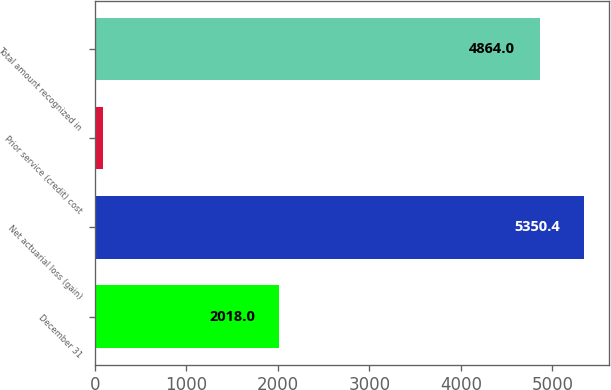<chart> <loc_0><loc_0><loc_500><loc_500><bar_chart><fcel>December 31<fcel>Net actuarial loss (gain)<fcel>Prior service (credit) cost<fcel>Total amount recognized in<nl><fcel>2018<fcel>5350.4<fcel>95<fcel>4864<nl></chart> 